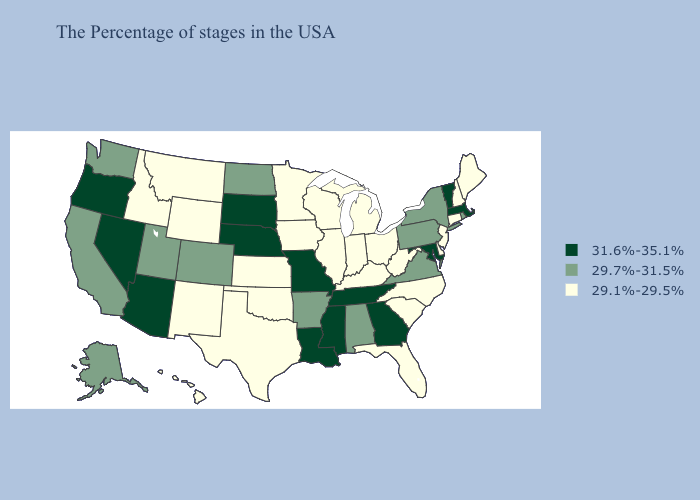What is the value of Idaho?
Give a very brief answer. 29.1%-29.5%. Does Arizona have a higher value than South Dakota?
Keep it brief. No. Name the states that have a value in the range 29.7%-31.5%?
Be succinct. Rhode Island, New York, Pennsylvania, Virginia, Alabama, Arkansas, North Dakota, Colorado, Utah, California, Washington, Alaska. Which states have the lowest value in the MidWest?
Answer briefly. Ohio, Michigan, Indiana, Wisconsin, Illinois, Minnesota, Iowa, Kansas. Among the states that border California , which have the highest value?
Quick response, please. Arizona, Nevada, Oregon. What is the lowest value in the MidWest?
Give a very brief answer. 29.1%-29.5%. Does New Mexico have the lowest value in the West?
Be succinct. Yes. Does the map have missing data?
Quick response, please. No. Does Maine have the lowest value in the Northeast?
Concise answer only. Yes. Which states have the lowest value in the USA?
Answer briefly. Maine, New Hampshire, Connecticut, New Jersey, Delaware, North Carolina, South Carolina, West Virginia, Ohio, Florida, Michigan, Kentucky, Indiana, Wisconsin, Illinois, Minnesota, Iowa, Kansas, Oklahoma, Texas, Wyoming, New Mexico, Montana, Idaho, Hawaii. What is the value of Oregon?
Write a very short answer. 31.6%-35.1%. Which states have the lowest value in the USA?
Keep it brief. Maine, New Hampshire, Connecticut, New Jersey, Delaware, North Carolina, South Carolina, West Virginia, Ohio, Florida, Michigan, Kentucky, Indiana, Wisconsin, Illinois, Minnesota, Iowa, Kansas, Oklahoma, Texas, Wyoming, New Mexico, Montana, Idaho, Hawaii. Which states have the lowest value in the South?
Be succinct. Delaware, North Carolina, South Carolina, West Virginia, Florida, Kentucky, Oklahoma, Texas. Does the map have missing data?
Be succinct. No. Name the states that have a value in the range 29.1%-29.5%?
Concise answer only. Maine, New Hampshire, Connecticut, New Jersey, Delaware, North Carolina, South Carolina, West Virginia, Ohio, Florida, Michigan, Kentucky, Indiana, Wisconsin, Illinois, Minnesota, Iowa, Kansas, Oklahoma, Texas, Wyoming, New Mexico, Montana, Idaho, Hawaii. 